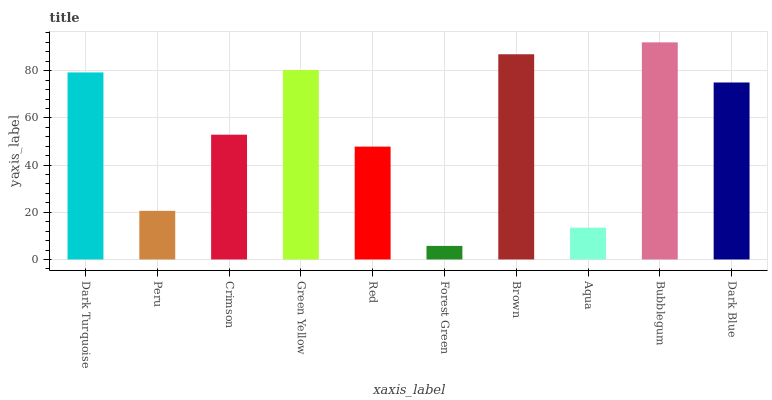Is Forest Green the minimum?
Answer yes or no. Yes. Is Bubblegum the maximum?
Answer yes or no. Yes. Is Peru the minimum?
Answer yes or no. No. Is Peru the maximum?
Answer yes or no. No. Is Dark Turquoise greater than Peru?
Answer yes or no. Yes. Is Peru less than Dark Turquoise?
Answer yes or no. Yes. Is Peru greater than Dark Turquoise?
Answer yes or no. No. Is Dark Turquoise less than Peru?
Answer yes or no. No. Is Dark Blue the high median?
Answer yes or no. Yes. Is Crimson the low median?
Answer yes or no. Yes. Is Green Yellow the high median?
Answer yes or no. No. Is Dark Blue the low median?
Answer yes or no. No. 